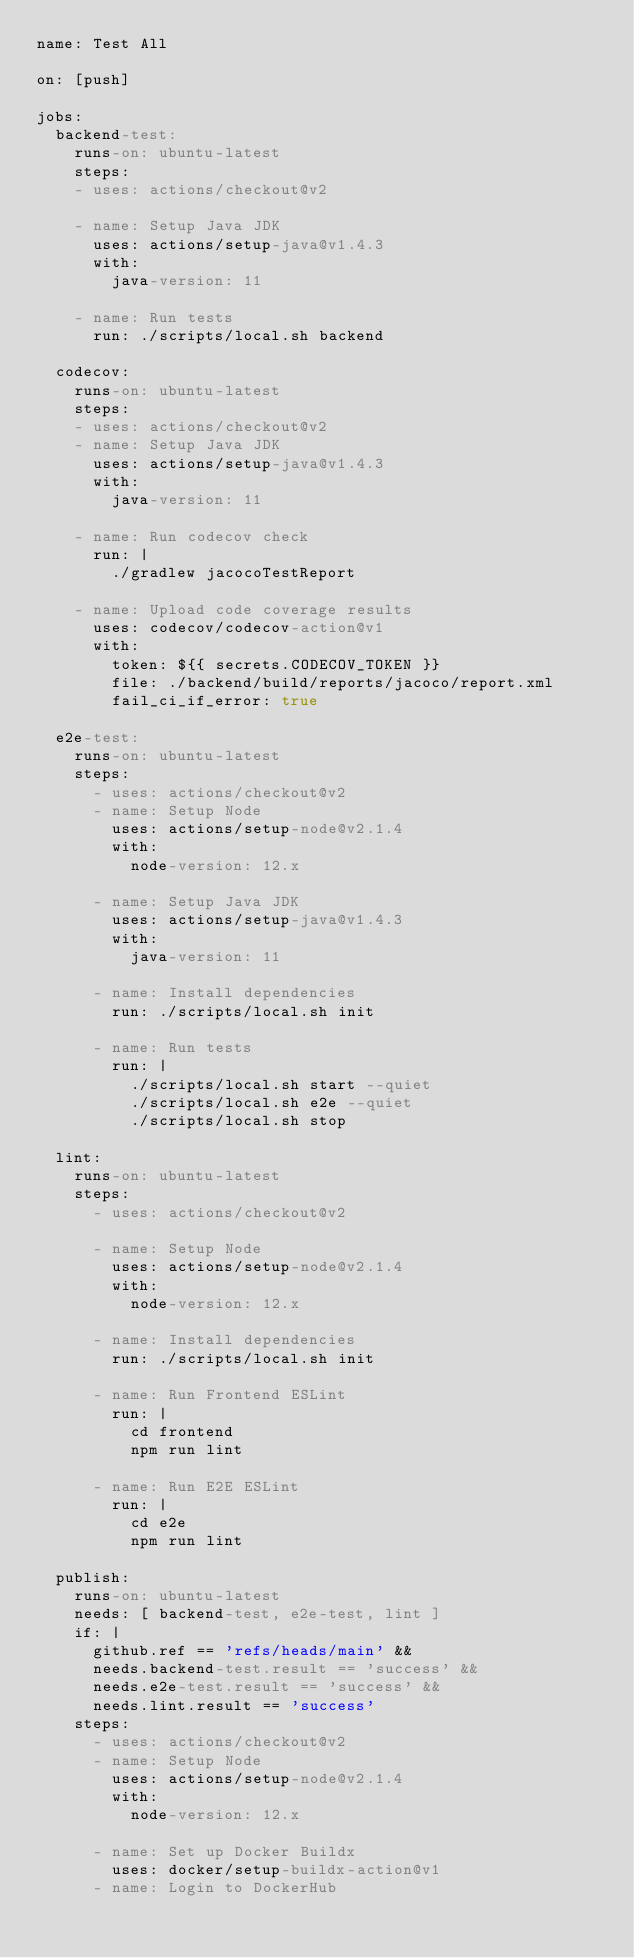Convert code to text. <code><loc_0><loc_0><loc_500><loc_500><_YAML_>name: Test All

on: [push]

jobs:
  backend-test:
    runs-on: ubuntu-latest
    steps:
    - uses: actions/checkout@v2

    - name: Setup Java JDK
      uses: actions/setup-java@v1.4.3
      with:
        java-version: 11

    - name: Run tests
      run: ./scripts/local.sh backend

  codecov:
    runs-on: ubuntu-latest
    steps:
    - uses: actions/checkout@v2
    - name: Setup Java JDK
      uses: actions/setup-java@v1.4.3
      with:
        java-version: 11

    - name: Run codecov check
      run: |
        ./gradlew jacocoTestReport

    - name: Upload code coverage results
      uses: codecov/codecov-action@v1
      with:
        token: ${{ secrets.CODECOV_TOKEN }}
        file: ./backend/build/reports/jacoco/report.xml
        fail_ci_if_error: true

  e2e-test:
    runs-on: ubuntu-latest
    steps:
      - uses: actions/checkout@v2
      - name: Setup Node
        uses: actions/setup-node@v2.1.4
        with:
          node-version: 12.x

      - name: Setup Java JDK
        uses: actions/setup-java@v1.4.3
        with:
          java-version: 11

      - name: Install dependencies
        run: ./scripts/local.sh init

      - name: Run tests
        run: |
          ./scripts/local.sh start --quiet
          ./scripts/local.sh e2e --quiet
          ./scripts/local.sh stop

  lint:
    runs-on: ubuntu-latest
    steps:
      - uses: actions/checkout@v2

      - name: Setup Node
        uses: actions/setup-node@v2.1.4
        with:
          node-version: 12.x

      - name: Install dependencies
        run: ./scripts/local.sh init

      - name: Run Frontend ESLint
        run: |
          cd frontend
          npm run lint

      - name: Run E2E ESLint
        run: |
          cd e2e
          npm run lint

  publish:
    runs-on: ubuntu-latest
    needs: [ backend-test, e2e-test, lint ]
    if: |
      github.ref == 'refs/heads/main' &&
      needs.backend-test.result == 'success' &&
      needs.e2e-test.result == 'success' &&
      needs.lint.result == 'success'
    steps:
      - uses: actions/checkout@v2
      - name: Setup Node
        uses: actions/setup-node@v2.1.4
        with:
          node-version: 12.x

      - name: Set up Docker Buildx
        uses: docker/setup-buildx-action@v1
      - name: Login to DockerHub</code> 